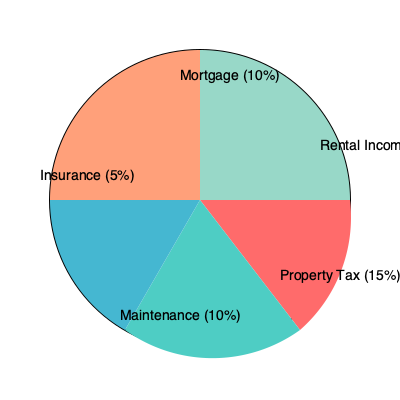A property in District 2 of Ho Chi Minh City generates an annual rental income of $120,000. Based on the expense distribution shown in the pie chart, calculate the Return on Investment (ROI) if the property was purchased for $1,000,000. To calculate the Return on Investment (ROI), we need to follow these steps:

1. Calculate the total annual income:
   - Rental income = $120,000 (given)

2. Calculate the total annual expenses:
   - Property Tax (15%): $120,000 × 15% = $18,000
   - Maintenance (10%): $120,000 × 10% = $12,000
   - Insurance (5%): $120,000 × 5% = $6,000
   - Mortgage (10%): $120,000 × 10% = $12,000
   - Total expenses: $18,000 + $12,000 + $6,000 + $12,000 = $48,000

3. Calculate the annual net income:
   Net income = Total income - Total expenses
   Net income = $120,000 - $48,000 = $72,000

4. Calculate the ROI:
   ROI = (Annual net income / Property purchase price) × 100%
   ROI = ($72,000 / $1,000,000) × 100% = 7.2%

Therefore, the Return on Investment (ROI) for this property is 7.2%.
Answer: 7.2% 